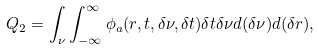Convert formula to latex. <formula><loc_0><loc_0><loc_500><loc_500>Q _ { 2 } = \int _ { \nu } \int _ { - \infty } ^ { \infty } \phi _ { a } ( { r } , t , \delta \nu , \delta t ) \delta t \delta \nu d ( \delta \nu ) d ( \delta { r } ) ,</formula> 